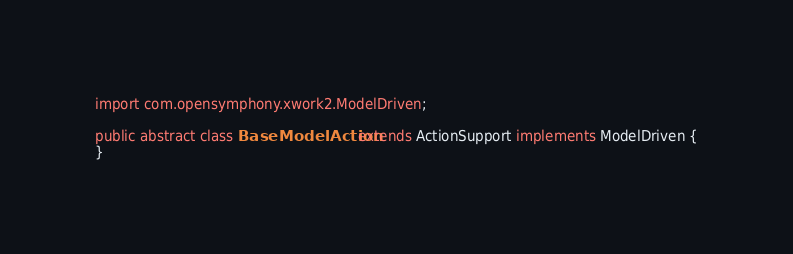Convert code to text. <code><loc_0><loc_0><loc_500><loc_500><_Java_>import com.opensymphony.xwork2.ModelDriven;

public abstract class BaseModelAction extends ActionSupport implements ModelDriven {
}
</code> 